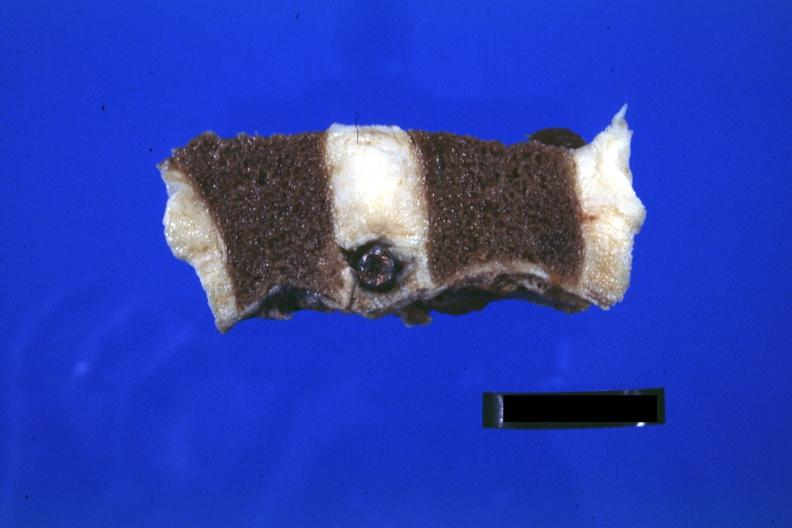what is present?
Answer the question using a single word or phrase. Joints 